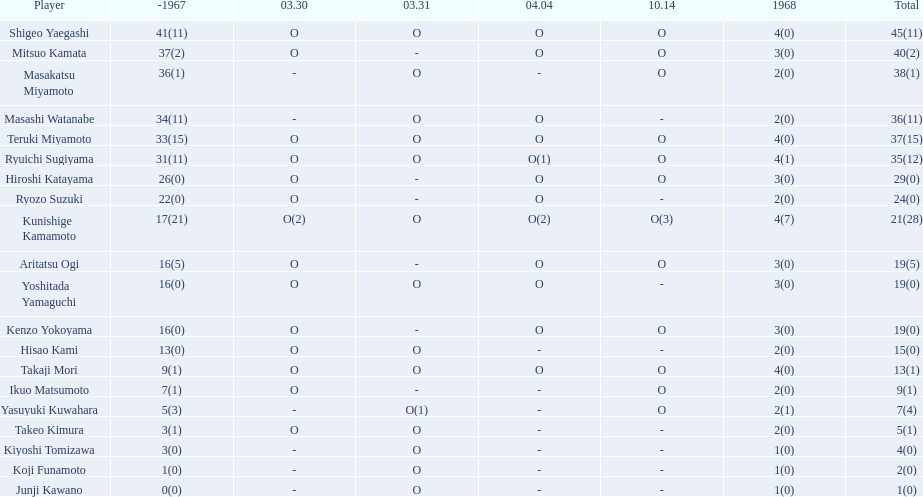How many points did takaji mori have? 13(1). And how many points did junji kawano have? 1(0). To who does the higher of these belong to? Takaji Mori. 